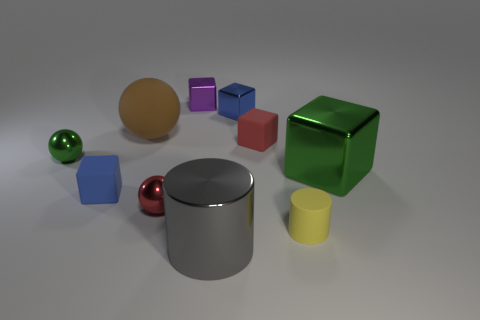There is a green object that is made of the same material as the green cube; what shape is it?
Make the answer very short. Sphere. What number of rubber things are brown objects or small blue blocks?
Your response must be concise. 2. Is the number of red shiny spheres that are behind the small blue metal thing the same as the number of tiny purple blocks?
Make the answer very short. No. There is a small ball that is left of the big brown sphere; is it the same color as the big metallic cube?
Your answer should be compact. Yes. There is a small cube that is both in front of the tiny purple shiny block and behind the brown ball; what is its material?
Offer a terse response. Metal. Is there a cylinder that is in front of the blue block in front of the big brown matte object?
Give a very brief answer. Yes. Is the big brown ball made of the same material as the green block?
Keep it short and to the point. No. There is a tiny matte thing that is in front of the tiny red block and on the right side of the purple metallic cube; what is its shape?
Your response must be concise. Cylinder. There is a sphere that is on the left side of the blue block that is in front of the green sphere; what is its size?
Ensure brevity in your answer.  Small. How many other tiny things have the same shape as the tiny purple metal thing?
Make the answer very short. 3. 